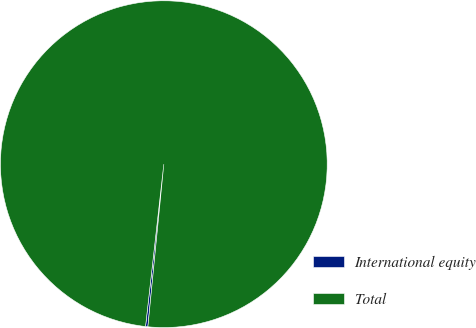Convert chart to OTSL. <chart><loc_0><loc_0><loc_500><loc_500><pie_chart><fcel>International equity<fcel>Total<nl><fcel>0.23%<fcel>99.77%<nl></chart> 